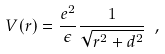<formula> <loc_0><loc_0><loc_500><loc_500>V ( r ) = \frac { e ^ { 2 } } { \epsilon } \frac { 1 } { \sqrt { r ^ { 2 } + d ^ { 2 } } } \ ,</formula> 